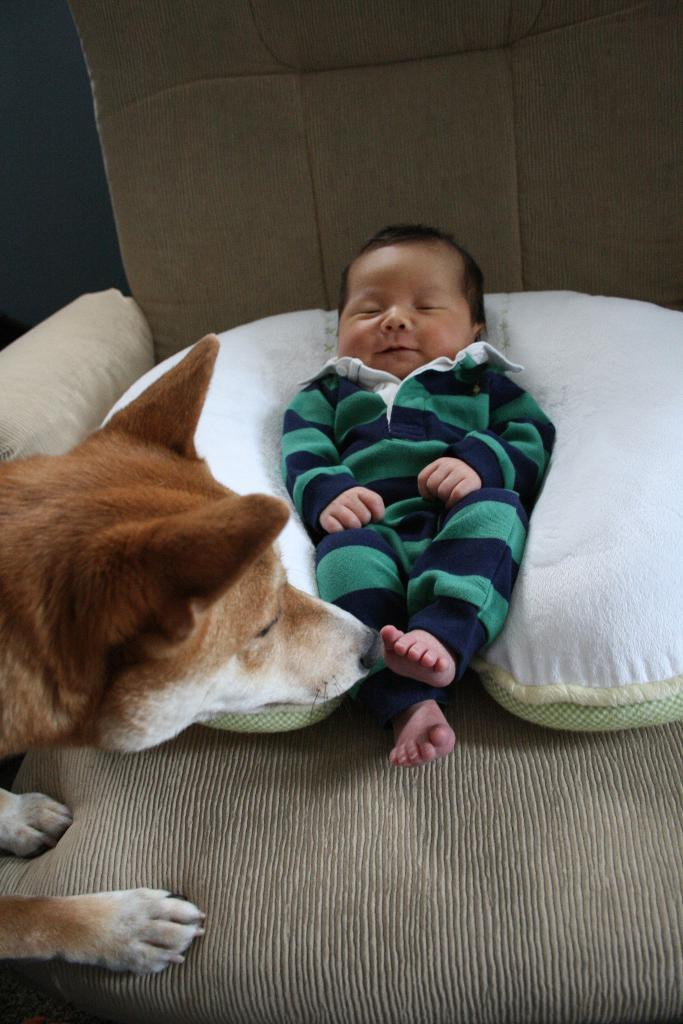What is the main subject of the image? The main subject of the image is a baby sleeping on a chair. Are there any other living beings in the image? Yes, there is a dog in the image. What type of corn is being used to make jam in the image? There is no corn or jam present in the image. What role does the actor play in the image? There is no actor present in the image. 